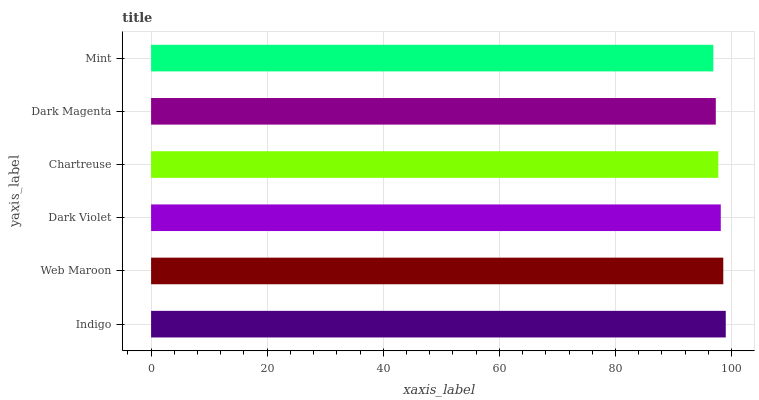Is Mint the minimum?
Answer yes or no. Yes. Is Indigo the maximum?
Answer yes or no. Yes. Is Web Maroon the minimum?
Answer yes or no. No. Is Web Maroon the maximum?
Answer yes or no. No. Is Indigo greater than Web Maroon?
Answer yes or no. Yes. Is Web Maroon less than Indigo?
Answer yes or no. Yes. Is Web Maroon greater than Indigo?
Answer yes or no. No. Is Indigo less than Web Maroon?
Answer yes or no. No. Is Dark Violet the high median?
Answer yes or no. Yes. Is Chartreuse the low median?
Answer yes or no. Yes. Is Dark Magenta the high median?
Answer yes or no. No. Is Dark Magenta the low median?
Answer yes or no. No. 